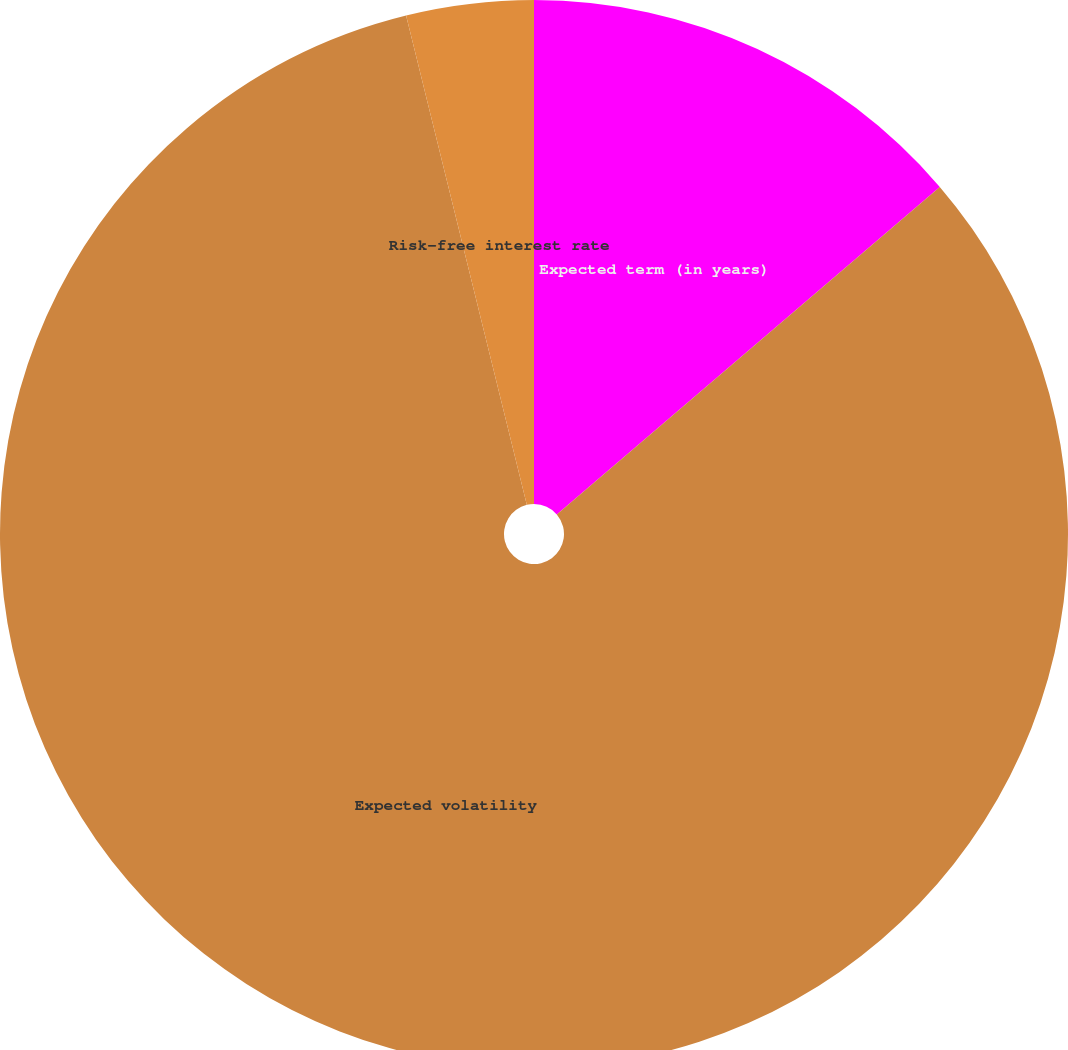Convert chart. <chart><loc_0><loc_0><loc_500><loc_500><pie_chart><fcel>Expected term (in years)<fcel>Expected volatility<fcel>Risk-free interest rate<nl><fcel>13.74%<fcel>82.42%<fcel>3.85%<nl></chart> 